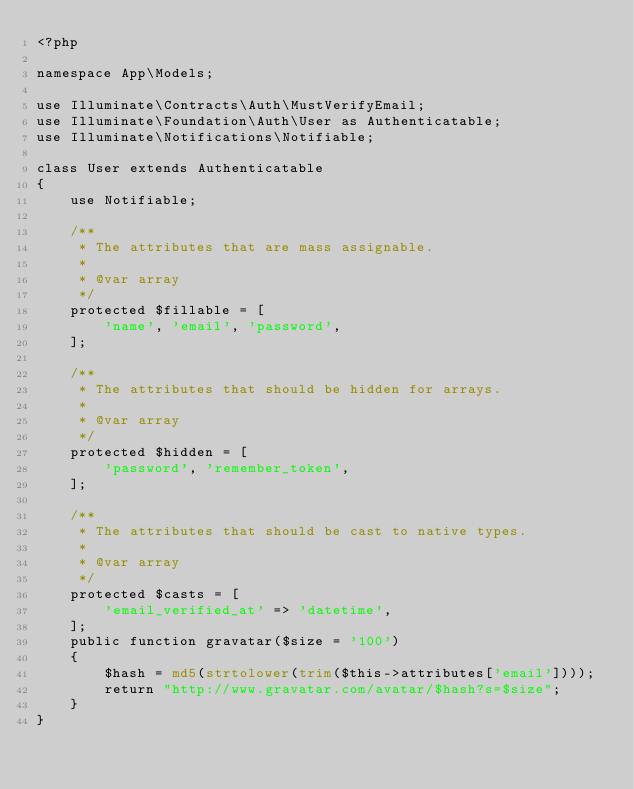<code> <loc_0><loc_0><loc_500><loc_500><_PHP_><?php

namespace App\Models;

use Illuminate\Contracts\Auth\MustVerifyEmail;
use Illuminate\Foundation\Auth\User as Authenticatable;
use Illuminate\Notifications\Notifiable;

class User extends Authenticatable
{
    use Notifiable;

    /**
     * The attributes that are mass assignable.
     *
     * @var array
     */
    protected $fillable = [
        'name', 'email', 'password',
    ];

    /**
     * The attributes that should be hidden for arrays.
     *
     * @var array
     */
    protected $hidden = [
        'password', 'remember_token',
    ];

    /**
     * The attributes that should be cast to native types.
     *
     * @var array
     */
    protected $casts = [
        'email_verified_at' => 'datetime',
    ];
    public function gravatar($size = '100')
    {
        $hash = md5(strtolower(trim($this->attributes['email'])));
        return "http://www.gravatar.com/avatar/$hash?s=$size";
    }
}
</code> 